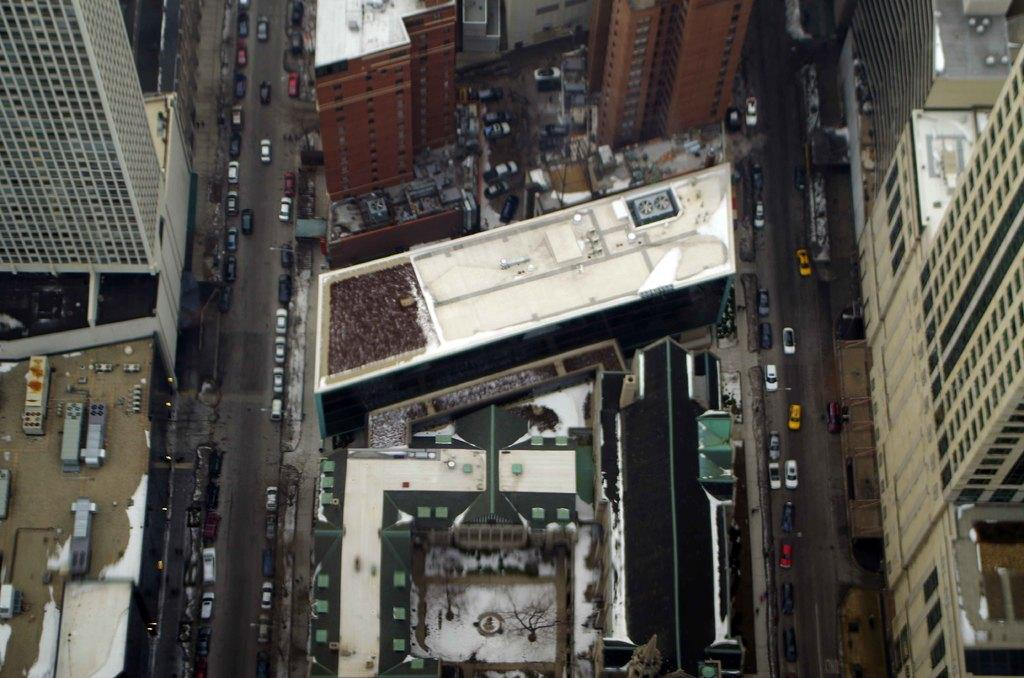What type of structures can be seen in the image? There are buildings in the image. What else is present in the image besides buildings? There are vehicles and trees visible in the image. What can be seen beneath the buildings and trees? The ground is visible in the image. What type of bait is being used to catch fish in the image? There is no fishing or bait present in the image; it features buildings, vehicles, and trees. How many cherries can be seen on the trees in the image? There are no cherries visible in the image; it features buildings, vehicles, and trees. 